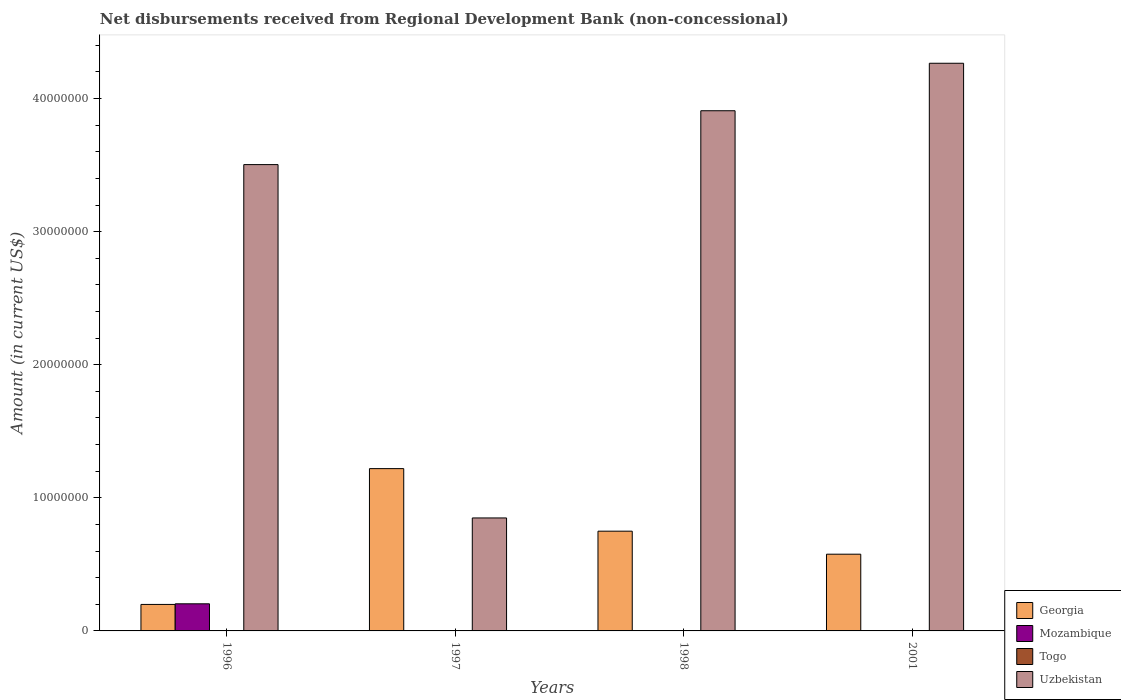How many different coloured bars are there?
Make the answer very short. 3. Are the number of bars per tick equal to the number of legend labels?
Provide a succinct answer. No. How many bars are there on the 4th tick from the left?
Your answer should be compact. 2. What is the amount of disbursements received from Regional Development Bank in Uzbekistan in 1998?
Make the answer very short. 3.91e+07. Across all years, what is the maximum amount of disbursements received from Regional Development Bank in Mozambique?
Your answer should be very brief. 2.04e+06. Across all years, what is the minimum amount of disbursements received from Regional Development Bank in Georgia?
Ensure brevity in your answer.  1.99e+06. What is the total amount of disbursements received from Regional Development Bank in Georgia in the graph?
Your response must be concise. 2.74e+07. What is the difference between the amount of disbursements received from Regional Development Bank in Uzbekistan in 1996 and that in 1998?
Ensure brevity in your answer.  -4.05e+06. What is the difference between the amount of disbursements received from Regional Development Bank in Uzbekistan in 1997 and the amount of disbursements received from Regional Development Bank in Togo in 1996?
Ensure brevity in your answer.  8.49e+06. In the year 1996, what is the difference between the amount of disbursements received from Regional Development Bank in Georgia and amount of disbursements received from Regional Development Bank in Uzbekistan?
Offer a very short reply. -3.30e+07. In how many years, is the amount of disbursements received from Regional Development Bank in Mozambique greater than 26000000 US$?
Give a very brief answer. 0. What is the ratio of the amount of disbursements received from Regional Development Bank in Georgia in 1997 to that in 1998?
Your response must be concise. 1.63. Is the difference between the amount of disbursements received from Regional Development Bank in Georgia in 1996 and 1998 greater than the difference between the amount of disbursements received from Regional Development Bank in Uzbekistan in 1996 and 1998?
Your answer should be very brief. No. What is the difference between the highest and the second highest amount of disbursements received from Regional Development Bank in Uzbekistan?
Offer a very short reply. 3.57e+06. What is the difference between the highest and the lowest amount of disbursements received from Regional Development Bank in Uzbekistan?
Make the answer very short. 3.42e+07. In how many years, is the amount of disbursements received from Regional Development Bank in Georgia greater than the average amount of disbursements received from Regional Development Bank in Georgia taken over all years?
Provide a succinct answer. 2. Is the sum of the amount of disbursements received from Regional Development Bank in Georgia in 1996 and 2001 greater than the maximum amount of disbursements received from Regional Development Bank in Uzbekistan across all years?
Provide a short and direct response. No. Is it the case that in every year, the sum of the amount of disbursements received from Regional Development Bank in Mozambique and amount of disbursements received from Regional Development Bank in Georgia is greater than the sum of amount of disbursements received from Regional Development Bank in Uzbekistan and amount of disbursements received from Regional Development Bank in Togo?
Offer a very short reply. No. Is it the case that in every year, the sum of the amount of disbursements received from Regional Development Bank in Georgia and amount of disbursements received from Regional Development Bank in Uzbekistan is greater than the amount of disbursements received from Regional Development Bank in Togo?
Provide a short and direct response. Yes. How many bars are there?
Your answer should be very brief. 9. Are the values on the major ticks of Y-axis written in scientific E-notation?
Make the answer very short. No. How are the legend labels stacked?
Offer a very short reply. Vertical. What is the title of the graph?
Keep it short and to the point. Net disbursements received from Regional Development Bank (non-concessional). What is the label or title of the X-axis?
Keep it short and to the point. Years. What is the label or title of the Y-axis?
Offer a very short reply. Amount (in current US$). What is the Amount (in current US$) in Georgia in 1996?
Make the answer very short. 1.99e+06. What is the Amount (in current US$) of Mozambique in 1996?
Your response must be concise. 2.04e+06. What is the Amount (in current US$) in Uzbekistan in 1996?
Keep it short and to the point. 3.50e+07. What is the Amount (in current US$) in Georgia in 1997?
Provide a short and direct response. 1.22e+07. What is the Amount (in current US$) in Uzbekistan in 1997?
Make the answer very short. 8.49e+06. What is the Amount (in current US$) of Georgia in 1998?
Provide a short and direct response. 7.49e+06. What is the Amount (in current US$) in Mozambique in 1998?
Your response must be concise. 0. What is the Amount (in current US$) in Uzbekistan in 1998?
Provide a succinct answer. 3.91e+07. What is the Amount (in current US$) in Georgia in 2001?
Your answer should be compact. 5.76e+06. What is the Amount (in current US$) of Togo in 2001?
Provide a succinct answer. 0. What is the Amount (in current US$) of Uzbekistan in 2001?
Keep it short and to the point. 4.27e+07. Across all years, what is the maximum Amount (in current US$) in Georgia?
Ensure brevity in your answer.  1.22e+07. Across all years, what is the maximum Amount (in current US$) in Mozambique?
Your answer should be compact. 2.04e+06. Across all years, what is the maximum Amount (in current US$) in Uzbekistan?
Offer a terse response. 4.27e+07. Across all years, what is the minimum Amount (in current US$) of Georgia?
Your answer should be very brief. 1.99e+06. Across all years, what is the minimum Amount (in current US$) in Mozambique?
Provide a succinct answer. 0. Across all years, what is the minimum Amount (in current US$) of Uzbekistan?
Keep it short and to the point. 8.49e+06. What is the total Amount (in current US$) of Georgia in the graph?
Your answer should be very brief. 2.74e+07. What is the total Amount (in current US$) of Mozambique in the graph?
Your response must be concise. 2.04e+06. What is the total Amount (in current US$) in Togo in the graph?
Give a very brief answer. 0. What is the total Amount (in current US$) of Uzbekistan in the graph?
Your answer should be very brief. 1.25e+08. What is the difference between the Amount (in current US$) of Georgia in 1996 and that in 1997?
Offer a very short reply. -1.02e+07. What is the difference between the Amount (in current US$) in Uzbekistan in 1996 and that in 1997?
Make the answer very short. 2.65e+07. What is the difference between the Amount (in current US$) in Georgia in 1996 and that in 1998?
Your answer should be very brief. -5.50e+06. What is the difference between the Amount (in current US$) in Uzbekistan in 1996 and that in 1998?
Your answer should be compact. -4.05e+06. What is the difference between the Amount (in current US$) of Georgia in 1996 and that in 2001?
Offer a terse response. -3.77e+06. What is the difference between the Amount (in current US$) in Uzbekistan in 1996 and that in 2001?
Give a very brief answer. -7.62e+06. What is the difference between the Amount (in current US$) in Georgia in 1997 and that in 1998?
Offer a very short reply. 4.70e+06. What is the difference between the Amount (in current US$) in Uzbekistan in 1997 and that in 1998?
Provide a succinct answer. -3.06e+07. What is the difference between the Amount (in current US$) in Georgia in 1997 and that in 2001?
Provide a short and direct response. 6.43e+06. What is the difference between the Amount (in current US$) in Uzbekistan in 1997 and that in 2001?
Keep it short and to the point. -3.42e+07. What is the difference between the Amount (in current US$) of Georgia in 1998 and that in 2001?
Your answer should be very brief. 1.73e+06. What is the difference between the Amount (in current US$) in Uzbekistan in 1998 and that in 2001?
Your response must be concise. -3.57e+06. What is the difference between the Amount (in current US$) of Georgia in 1996 and the Amount (in current US$) of Uzbekistan in 1997?
Keep it short and to the point. -6.50e+06. What is the difference between the Amount (in current US$) of Mozambique in 1996 and the Amount (in current US$) of Uzbekistan in 1997?
Your answer should be compact. -6.45e+06. What is the difference between the Amount (in current US$) in Georgia in 1996 and the Amount (in current US$) in Uzbekistan in 1998?
Offer a very short reply. -3.71e+07. What is the difference between the Amount (in current US$) in Mozambique in 1996 and the Amount (in current US$) in Uzbekistan in 1998?
Offer a terse response. -3.70e+07. What is the difference between the Amount (in current US$) of Georgia in 1996 and the Amount (in current US$) of Uzbekistan in 2001?
Keep it short and to the point. -4.07e+07. What is the difference between the Amount (in current US$) in Mozambique in 1996 and the Amount (in current US$) in Uzbekistan in 2001?
Provide a short and direct response. -4.06e+07. What is the difference between the Amount (in current US$) of Georgia in 1997 and the Amount (in current US$) of Uzbekistan in 1998?
Your answer should be compact. -2.69e+07. What is the difference between the Amount (in current US$) in Georgia in 1997 and the Amount (in current US$) in Uzbekistan in 2001?
Your answer should be compact. -3.05e+07. What is the difference between the Amount (in current US$) in Georgia in 1998 and the Amount (in current US$) in Uzbekistan in 2001?
Offer a terse response. -3.52e+07. What is the average Amount (in current US$) of Georgia per year?
Your answer should be very brief. 6.86e+06. What is the average Amount (in current US$) in Mozambique per year?
Give a very brief answer. 5.09e+05. What is the average Amount (in current US$) in Togo per year?
Make the answer very short. 0. What is the average Amount (in current US$) of Uzbekistan per year?
Make the answer very short. 3.13e+07. In the year 1996, what is the difference between the Amount (in current US$) in Georgia and Amount (in current US$) in Mozambique?
Offer a terse response. -4.60e+04. In the year 1996, what is the difference between the Amount (in current US$) of Georgia and Amount (in current US$) of Uzbekistan?
Your answer should be very brief. -3.30e+07. In the year 1996, what is the difference between the Amount (in current US$) of Mozambique and Amount (in current US$) of Uzbekistan?
Make the answer very short. -3.30e+07. In the year 1997, what is the difference between the Amount (in current US$) of Georgia and Amount (in current US$) of Uzbekistan?
Your response must be concise. 3.71e+06. In the year 1998, what is the difference between the Amount (in current US$) of Georgia and Amount (in current US$) of Uzbekistan?
Ensure brevity in your answer.  -3.16e+07. In the year 2001, what is the difference between the Amount (in current US$) in Georgia and Amount (in current US$) in Uzbekistan?
Make the answer very short. -3.69e+07. What is the ratio of the Amount (in current US$) in Georgia in 1996 to that in 1997?
Keep it short and to the point. 0.16. What is the ratio of the Amount (in current US$) in Uzbekistan in 1996 to that in 1997?
Keep it short and to the point. 4.13. What is the ratio of the Amount (in current US$) in Georgia in 1996 to that in 1998?
Your answer should be compact. 0.27. What is the ratio of the Amount (in current US$) in Uzbekistan in 1996 to that in 1998?
Ensure brevity in your answer.  0.9. What is the ratio of the Amount (in current US$) of Georgia in 1996 to that in 2001?
Your answer should be compact. 0.35. What is the ratio of the Amount (in current US$) of Uzbekistan in 1996 to that in 2001?
Make the answer very short. 0.82. What is the ratio of the Amount (in current US$) in Georgia in 1997 to that in 1998?
Give a very brief answer. 1.63. What is the ratio of the Amount (in current US$) in Uzbekistan in 1997 to that in 1998?
Your answer should be compact. 0.22. What is the ratio of the Amount (in current US$) of Georgia in 1997 to that in 2001?
Your answer should be compact. 2.12. What is the ratio of the Amount (in current US$) of Uzbekistan in 1997 to that in 2001?
Your answer should be very brief. 0.2. What is the ratio of the Amount (in current US$) in Georgia in 1998 to that in 2001?
Make the answer very short. 1.3. What is the ratio of the Amount (in current US$) of Uzbekistan in 1998 to that in 2001?
Make the answer very short. 0.92. What is the difference between the highest and the second highest Amount (in current US$) in Georgia?
Keep it short and to the point. 4.70e+06. What is the difference between the highest and the second highest Amount (in current US$) of Uzbekistan?
Your answer should be very brief. 3.57e+06. What is the difference between the highest and the lowest Amount (in current US$) in Georgia?
Ensure brevity in your answer.  1.02e+07. What is the difference between the highest and the lowest Amount (in current US$) in Mozambique?
Provide a succinct answer. 2.04e+06. What is the difference between the highest and the lowest Amount (in current US$) in Uzbekistan?
Offer a terse response. 3.42e+07. 